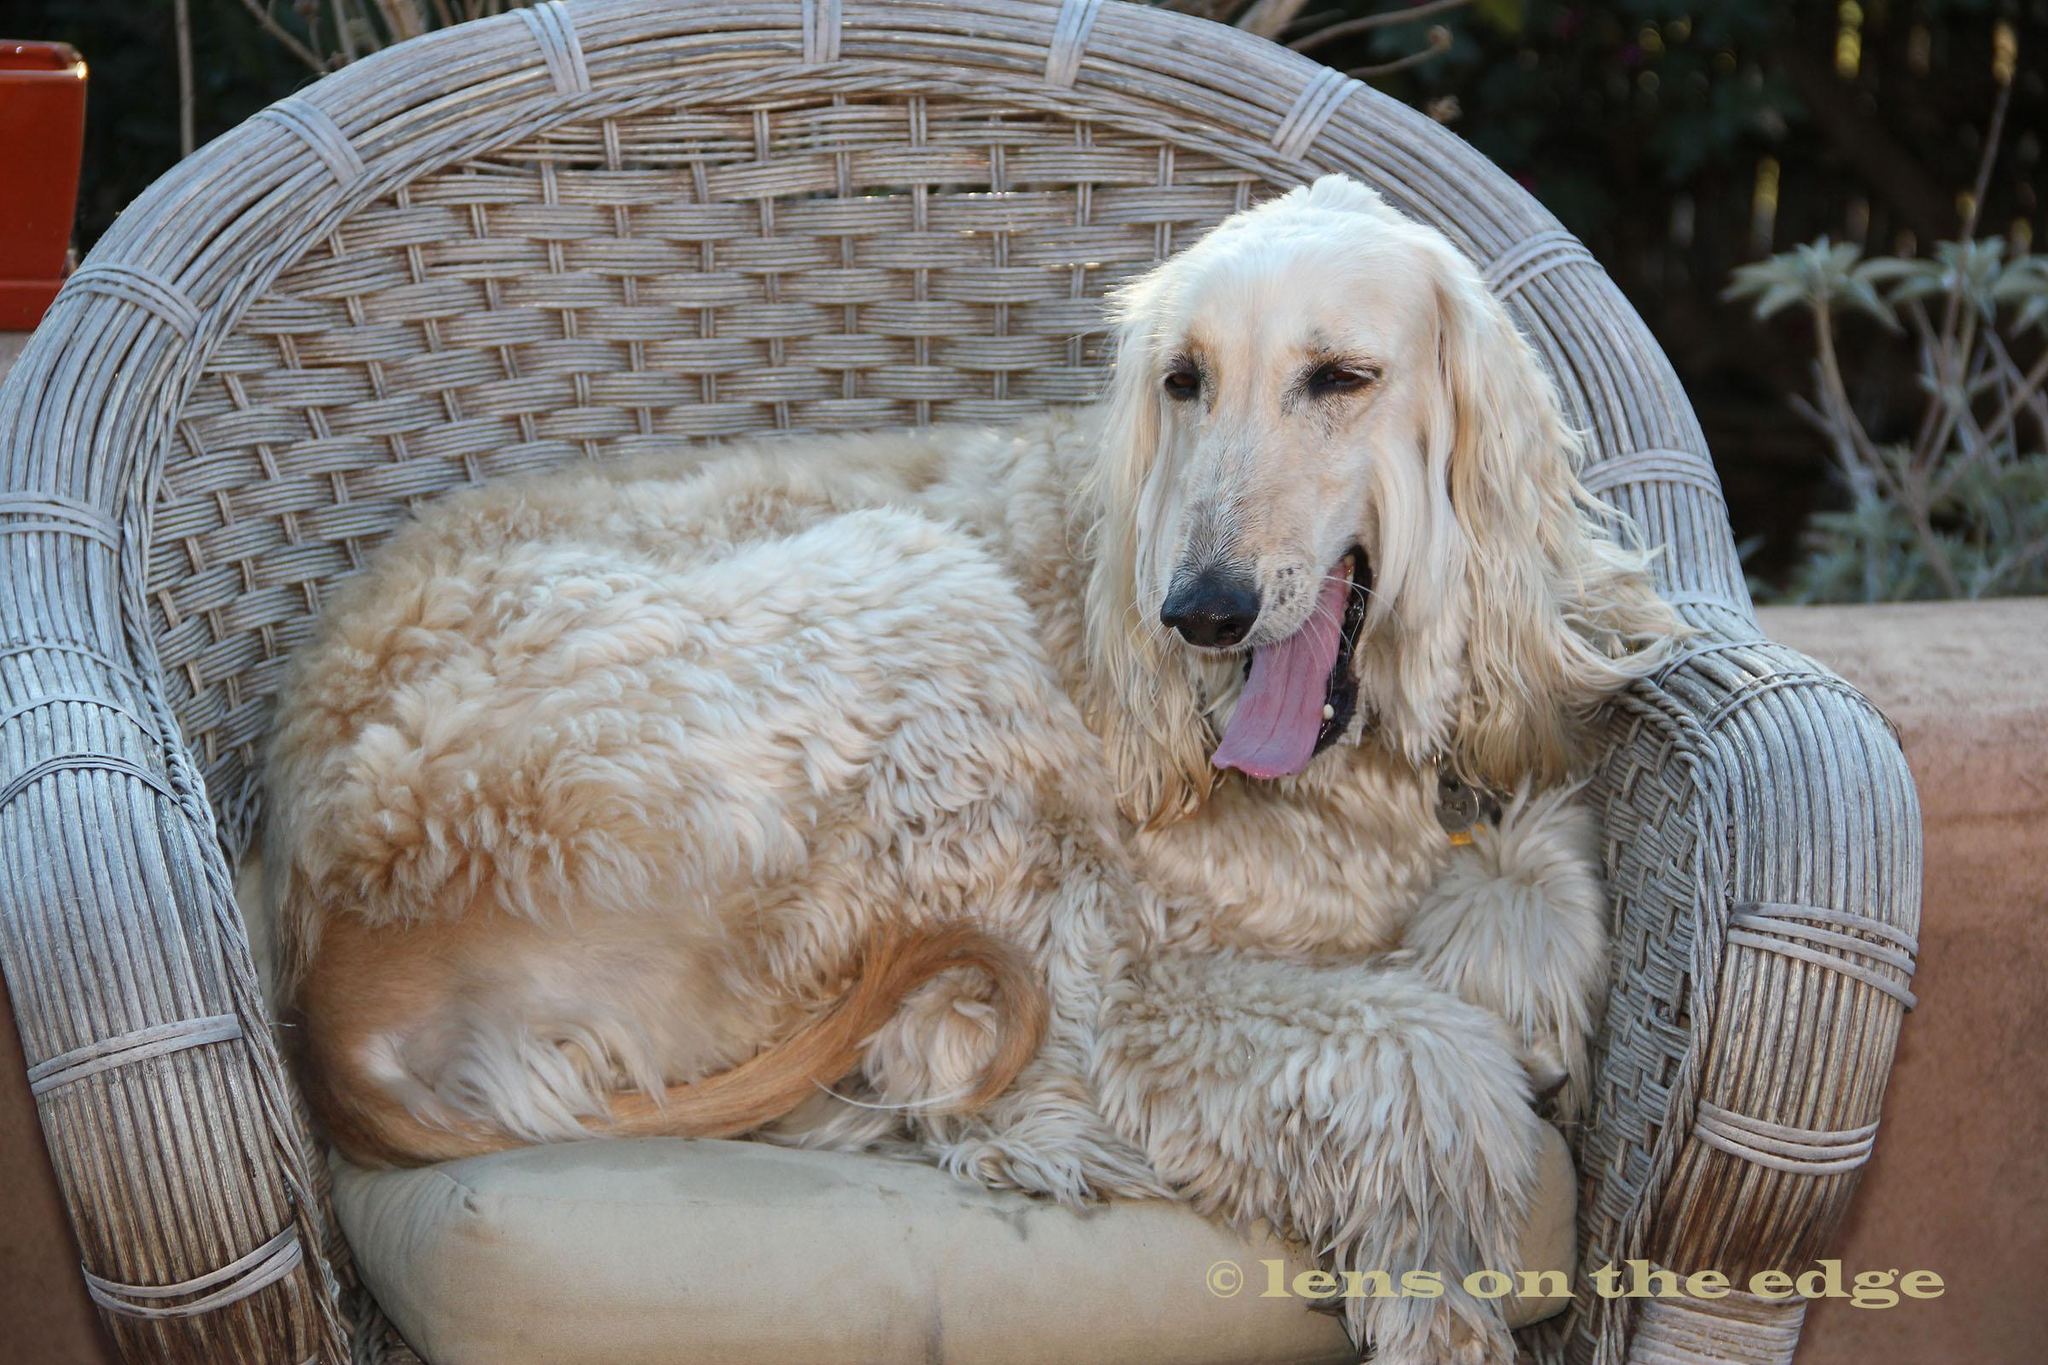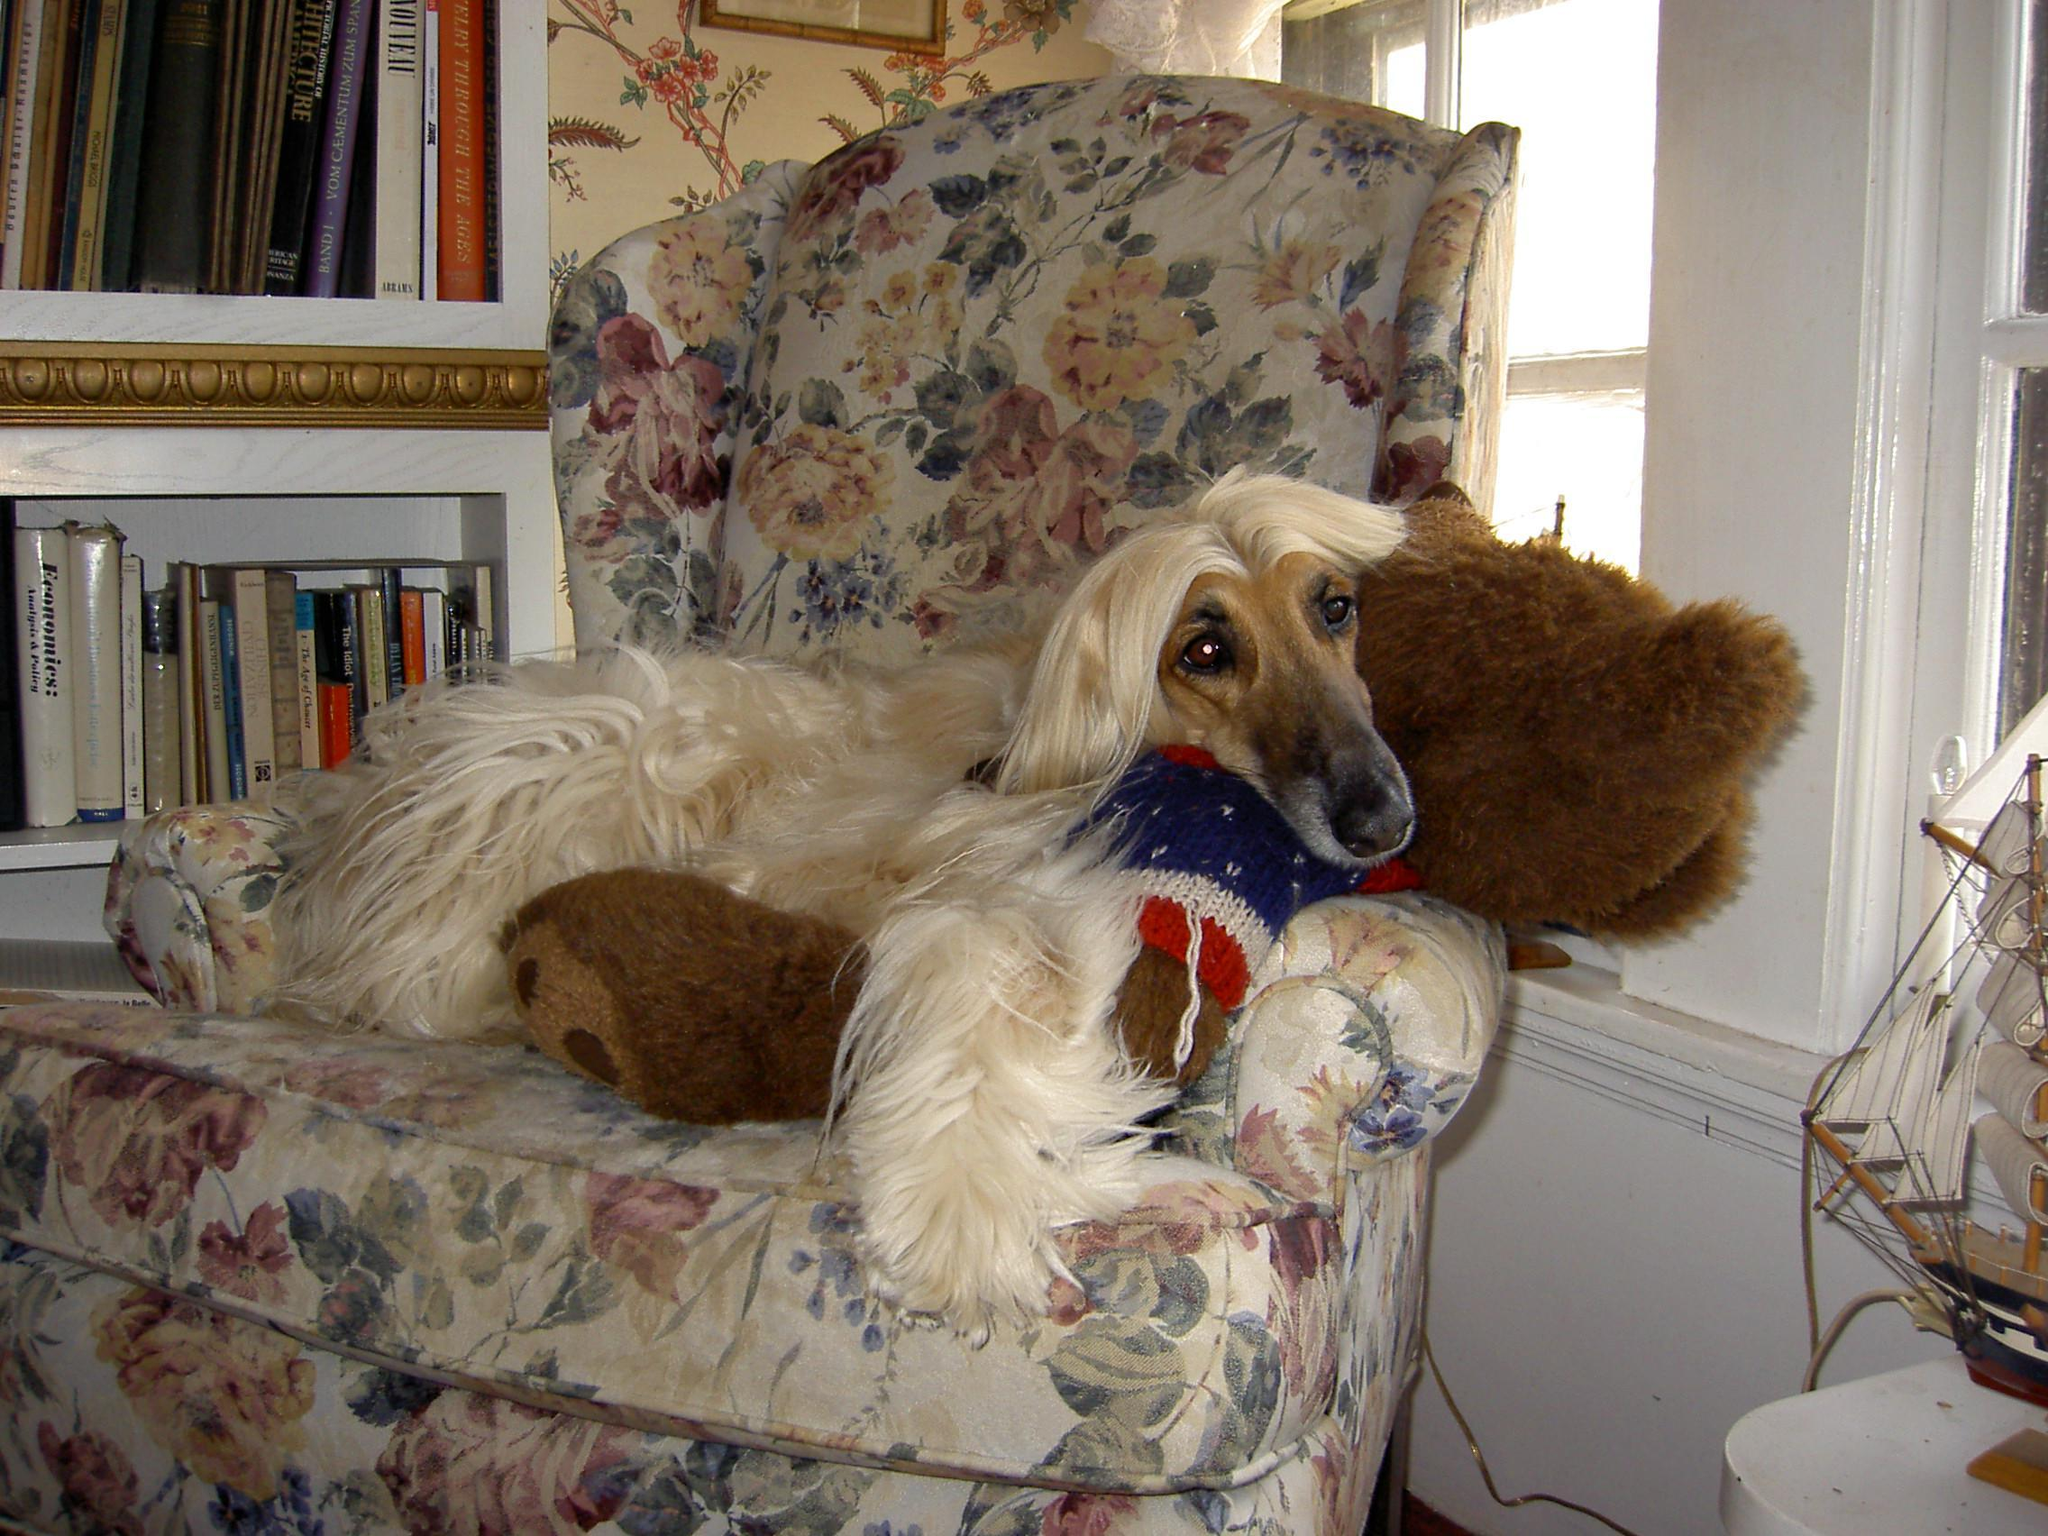The first image is the image on the left, the second image is the image on the right. Examine the images to the left and right. Is the description "An image shows a hound sleeping on a solid-white fabric-covered furniture item." accurate? Answer yes or no. No. The first image is the image on the left, the second image is the image on the right. Analyze the images presented: Is the assertion "In one image, a large light colored dog with very long hair is lounging on the arm of an overstuffed chair inside a home." valid? Answer yes or no. Yes. 